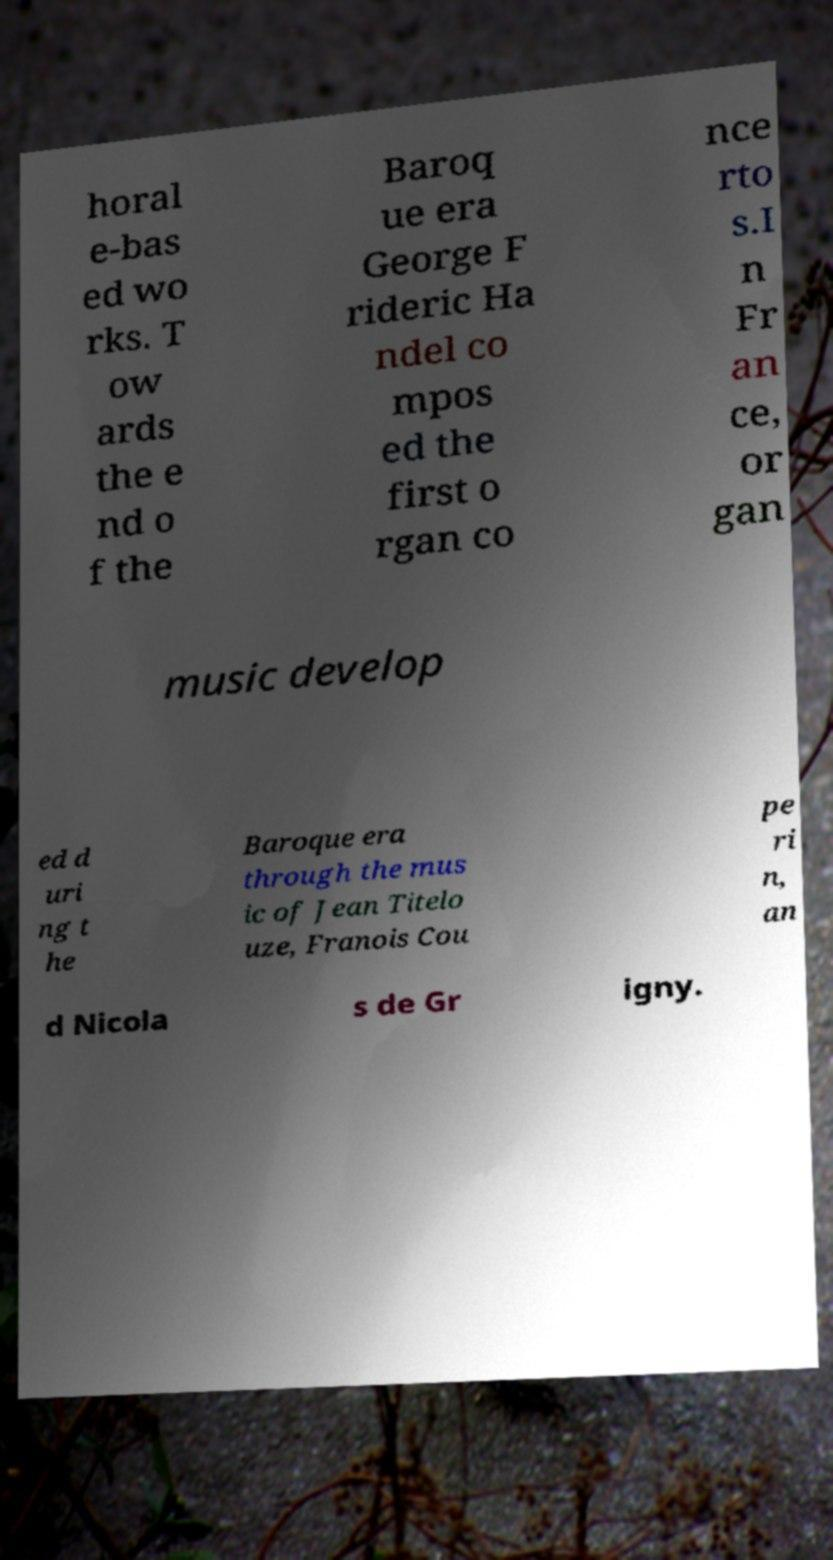What messages or text are displayed in this image? I need them in a readable, typed format. horal e-bas ed wo rks. T ow ards the e nd o f the Baroq ue era George F rideric Ha ndel co mpos ed the first o rgan co nce rto s.I n Fr an ce, or gan music develop ed d uri ng t he Baroque era through the mus ic of Jean Titelo uze, Franois Cou pe ri n, an d Nicola s de Gr igny. 